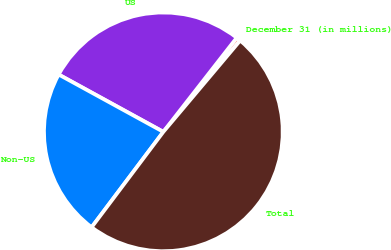Convert chart. <chart><loc_0><loc_0><loc_500><loc_500><pie_chart><fcel>December 31 (in millions)<fcel>US<fcel>Non-US<fcel>Total<nl><fcel>0.59%<fcel>27.57%<fcel>22.72%<fcel>49.13%<nl></chart> 